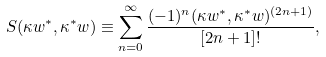<formula> <loc_0><loc_0><loc_500><loc_500>S ( \kappa w ^ { \ast } , \kappa ^ { \ast } w ) \equiv \sum _ { n = 0 } ^ { \infty } \frac { ( - 1 ) ^ { n } ( \kappa w ^ { \ast } , \kappa ^ { \ast } w ) ^ { ( 2 n + 1 ) } } { [ 2 n + 1 ] ! } ,</formula> 